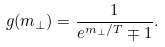Convert formula to latex. <formula><loc_0><loc_0><loc_500><loc_500>g ( m _ { \perp } ) = \frac { 1 } { e ^ { m _ { \perp } / T } \mp 1 } .</formula> 